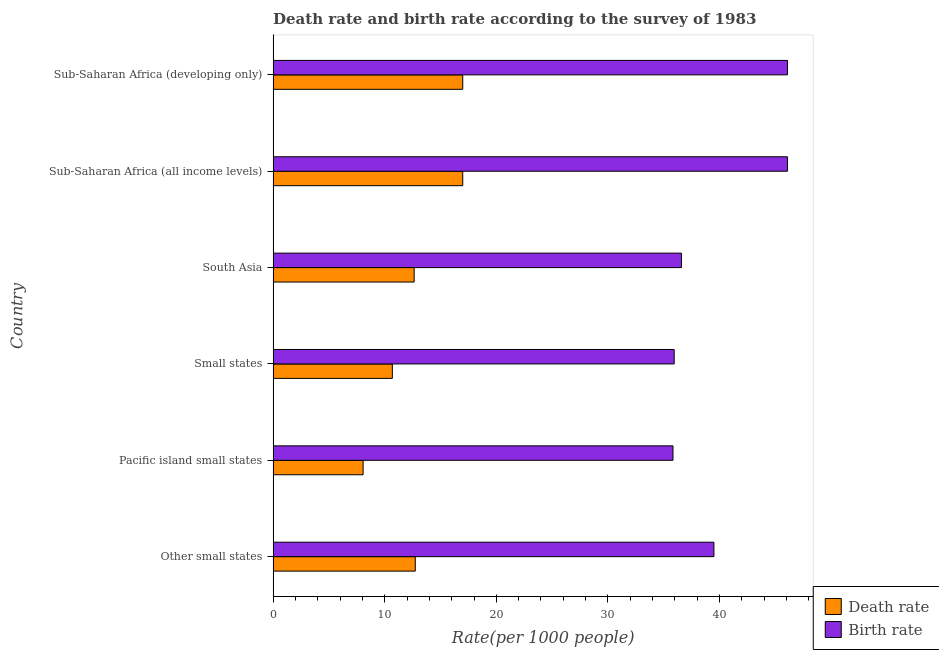How many different coloured bars are there?
Provide a short and direct response. 2. How many groups of bars are there?
Provide a short and direct response. 6. Are the number of bars on each tick of the Y-axis equal?
Give a very brief answer. Yes. What is the label of the 6th group of bars from the top?
Make the answer very short. Other small states. In how many cases, is the number of bars for a given country not equal to the number of legend labels?
Provide a succinct answer. 0. What is the death rate in Other small states?
Provide a short and direct response. 12.74. Across all countries, what is the maximum death rate?
Give a very brief answer. 16.99. Across all countries, what is the minimum death rate?
Provide a succinct answer. 8.06. In which country was the birth rate maximum?
Offer a very short reply. Sub-Saharan Africa (developing only). In which country was the birth rate minimum?
Give a very brief answer. Pacific island small states. What is the total death rate in the graph?
Your answer should be very brief. 78.1. What is the difference between the birth rate in Pacific island small states and that in Small states?
Provide a short and direct response. -0.11. What is the difference between the birth rate in Sub-Saharan Africa (all income levels) and the death rate in Sub-Saharan Africa (developing only)?
Provide a succinct answer. 29.1. What is the average birth rate per country?
Offer a terse response. 40.01. What is the difference between the death rate and birth rate in South Asia?
Provide a short and direct response. -23.95. In how many countries, is the birth rate greater than 20 ?
Provide a short and direct response. 6. Is the birth rate in Other small states less than that in South Asia?
Keep it short and to the point. No. Is the difference between the death rate in Pacific island small states and Sub-Saharan Africa (all income levels) greater than the difference between the birth rate in Pacific island small states and Sub-Saharan Africa (all income levels)?
Keep it short and to the point. Yes. What is the difference between the highest and the lowest birth rate?
Provide a short and direct response. 10.26. Is the sum of the birth rate in Other small states and Small states greater than the maximum death rate across all countries?
Offer a very short reply. Yes. What does the 1st bar from the top in Small states represents?
Provide a short and direct response. Birth rate. What does the 2nd bar from the bottom in South Asia represents?
Make the answer very short. Birth rate. How many bars are there?
Your answer should be very brief. 12. How many countries are there in the graph?
Provide a short and direct response. 6. Does the graph contain any zero values?
Ensure brevity in your answer.  No. Does the graph contain grids?
Your answer should be very brief. No. Where does the legend appear in the graph?
Provide a short and direct response. Bottom right. How many legend labels are there?
Your answer should be compact. 2. How are the legend labels stacked?
Make the answer very short. Vertical. What is the title of the graph?
Your answer should be compact. Death rate and birth rate according to the survey of 1983. Does "Automatic Teller Machines" appear as one of the legend labels in the graph?
Provide a succinct answer. No. What is the label or title of the X-axis?
Give a very brief answer. Rate(per 1000 people). What is the label or title of the Y-axis?
Give a very brief answer. Country. What is the Rate(per 1000 people) of Death rate in Other small states?
Provide a short and direct response. 12.74. What is the Rate(per 1000 people) in Birth rate in Other small states?
Give a very brief answer. 39.5. What is the Rate(per 1000 people) in Death rate in Pacific island small states?
Provide a succinct answer. 8.06. What is the Rate(per 1000 people) in Birth rate in Pacific island small states?
Make the answer very short. 35.83. What is the Rate(per 1000 people) in Death rate in Small states?
Provide a succinct answer. 10.68. What is the Rate(per 1000 people) in Birth rate in Small states?
Offer a very short reply. 35.94. What is the Rate(per 1000 people) of Death rate in South Asia?
Your answer should be compact. 12.64. What is the Rate(per 1000 people) in Birth rate in South Asia?
Your response must be concise. 36.59. What is the Rate(per 1000 people) of Death rate in Sub-Saharan Africa (all income levels)?
Your response must be concise. 16.99. What is the Rate(per 1000 people) of Birth rate in Sub-Saharan Africa (all income levels)?
Ensure brevity in your answer.  46.09. What is the Rate(per 1000 people) of Death rate in Sub-Saharan Africa (developing only)?
Give a very brief answer. 16.99. What is the Rate(per 1000 people) of Birth rate in Sub-Saharan Africa (developing only)?
Provide a short and direct response. 46.09. Across all countries, what is the maximum Rate(per 1000 people) in Death rate?
Make the answer very short. 16.99. Across all countries, what is the maximum Rate(per 1000 people) of Birth rate?
Make the answer very short. 46.09. Across all countries, what is the minimum Rate(per 1000 people) in Death rate?
Provide a short and direct response. 8.06. Across all countries, what is the minimum Rate(per 1000 people) in Birth rate?
Your response must be concise. 35.83. What is the total Rate(per 1000 people) in Death rate in the graph?
Provide a succinct answer. 78.1. What is the total Rate(per 1000 people) in Birth rate in the graph?
Your response must be concise. 240.04. What is the difference between the Rate(per 1000 people) in Death rate in Other small states and that in Pacific island small states?
Provide a succinct answer. 4.68. What is the difference between the Rate(per 1000 people) of Birth rate in Other small states and that in Pacific island small states?
Ensure brevity in your answer.  3.67. What is the difference between the Rate(per 1000 people) in Death rate in Other small states and that in Small states?
Ensure brevity in your answer.  2.06. What is the difference between the Rate(per 1000 people) of Birth rate in Other small states and that in Small states?
Your answer should be compact. 3.56. What is the difference between the Rate(per 1000 people) of Death rate in Other small states and that in South Asia?
Ensure brevity in your answer.  0.1. What is the difference between the Rate(per 1000 people) of Birth rate in Other small states and that in South Asia?
Your response must be concise. 2.91. What is the difference between the Rate(per 1000 people) in Death rate in Other small states and that in Sub-Saharan Africa (all income levels)?
Offer a terse response. -4.25. What is the difference between the Rate(per 1000 people) in Birth rate in Other small states and that in Sub-Saharan Africa (all income levels)?
Keep it short and to the point. -6.59. What is the difference between the Rate(per 1000 people) in Death rate in Other small states and that in Sub-Saharan Africa (developing only)?
Your answer should be very brief. -4.25. What is the difference between the Rate(per 1000 people) in Birth rate in Other small states and that in Sub-Saharan Africa (developing only)?
Your answer should be compact. -6.59. What is the difference between the Rate(per 1000 people) of Death rate in Pacific island small states and that in Small states?
Give a very brief answer. -2.62. What is the difference between the Rate(per 1000 people) of Birth rate in Pacific island small states and that in Small states?
Give a very brief answer. -0.11. What is the difference between the Rate(per 1000 people) in Death rate in Pacific island small states and that in South Asia?
Offer a very short reply. -4.58. What is the difference between the Rate(per 1000 people) of Birth rate in Pacific island small states and that in South Asia?
Give a very brief answer. -0.76. What is the difference between the Rate(per 1000 people) in Death rate in Pacific island small states and that in Sub-Saharan Africa (all income levels)?
Your answer should be very brief. -8.93. What is the difference between the Rate(per 1000 people) of Birth rate in Pacific island small states and that in Sub-Saharan Africa (all income levels)?
Provide a succinct answer. -10.26. What is the difference between the Rate(per 1000 people) of Death rate in Pacific island small states and that in Sub-Saharan Africa (developing only)?
Make the answer very short. -8.93. What is the difference between the Rate(per 1000 people) in Birth rate in Pacific island small states and that in Sub-Saharan Africa (developing only)?
Provide a short and direct response. -10.26. What is the difference between the Rate(per 1000 people) of Death rate in Small states and that in South Asia?
Offer a very short reply. -1.96. What is the difference between the Rate(per 1000 people) of Birth rate in Small states and that in South Asia?
Provide a short and direct response. -0.65. What is the difference between the Rate(per 1000 people) in Death rate in Small states and that in Sub-Saharan Africa (all income levels)?
Your answer should be compact. -6.31. What is the difference between the Rate(per 1000 people) in Birth rate in Small states and that in Sub-Saharan Africa (all income levels)?
Provide a succinct answer. -10.15. What is the difference between the Rate(per 1000 people) of Death rate in Small states and that in Sub-Saharan Africa (developing only)?
Give a very brief answer. -6.31. What is the difference between the Rate(per 1000 people) of Birth rate in Small states and that in Sub-Saharan Africa (developing only)?
Offer a terse response. -10.16. What is the difference between the Rate(per 1000 people) of Death rate in South Asia and that in Sub-Saharan Africa (all income levels)?
Provide a short and direct response. -4.35. What is the difference between the Rate(per 1000 people) in Birth rate in South Asia and that in Sub-Saharan Africa (all income levels)?
Provide a succinct answer. -9.5. What is the difference between the Rate(per 1000 people) of Death rate in South Asia and that in Sub-Saharan Africa (developing only)?
Provide a succinct answer. -4.35. What is the difference between the Rate(per 1000 people) in Birth rate in South Asia and that in Sub-Saharan Africa (developing only)?
Offer a very short reply. -9.5. What is the difference between the Rate(per 1000 people) in Birth rate in Sub-Saharan Africa (all income levels) and that in Sub-Saharan Africa (developing only)?
Your answer should be compact. -0.01. What is the difference between the Rate(per 1000 people) of Death rate in Other small states and the Rate(per 1000 people) of Birth rate in Pacific island small states?
Your response must be concise. -23.09. What is the difference between the Rate(per 1000 people) of Death rate in Other small states and the Rate(per 1000 people) of Birth rate in Small states?
Your answer should be very brief. -23.2. What is the difference between the Rate(per 1000 people) of Death rate in Other small states and the Rate(per 1000 people) of Birth rate in South Asia?
Offer a very short reply. -23.85. What is the difference between the Rate(per 1000 people) in Death rate in Other small states and the Rate(per 1000 people) in Birth rate in Sub-Saharan Africa (all income levels)?
Keep it short and to the point. -33.35. What is the difference between the Rate(per 1000 people) of Death rate in Other small states and the Rate(per 1000 people) of Birth rate in Sub-Saharan Africa (developing only)?
Your response must be concise. -33.36. What is the difference between the Rate(per 1000 people) of Death rate in Pacific island small states and the Rate(per 1000 people) of Birth rate in Small states?
Your answer should be very brief. -27.88. What is the difference between the Rate(per 1000 people) in Death rate in Pacific island small states and the Rate(per 1000 people) in Birth rate in South Asia?
Provide a succinct answer. -28.53. What is the difference between the Rate(per 1000 people) in Death rate in Pacific island small states and the Rate(per 1000 people) in Birth rate in Sub-Saharan Africa (all income levels)?
Provide a short and direct response. -38.03. What is the difference between the Rate(per 1000 people) of Death rate in Pacific island small states and the Rate(per 1000 people) of Birth rate in Sub-Saharan Africa (developing only)?
Your answer should be very brief. -38.03. What is the difference between the Rate(per 1000 people) of Death rate in Small states and the Rate(per 1000 people) of Birth rate in South Asia?
Provide a short and direct response. -25.91. What is the difference between the Rate(per 1000 people) of Death rate in Small states and the Rate(per 1000 people) of Birth rate in Sub-Saharan Africa (all income levels)?
Ensure brevity in your answer.  -35.41. What is the difference between the Rate(per 1000 people) in Death rate in Small states and the Rate(per 1000 people) in Birth rate in Sub-Saharan Africa (developing only)?
Keep it short and to the point. -35.41. What is the difference between the Rate(per 1000 people) of Death rate in South Asia and the Rate(per 1000 people) of Birth rate in Sub-Saharan Africa (all income levels)?
Provide a short and direct response. -33.45. What is the difference between the Rate(per 1000 people) in Death rate in South Asia and the Rate(per 1000 people) in Birth rate in Sub-Saharan Africa (developing only)?
Keep it short and to the point. -33.45. What is the difference between the Rate(per 1000 people) of Death rate in Sub-Saharan Africa (all income levels) and the Rate(per 1000 people) of Birth rate in Sub-Saharan Africa (developing only)?
Offer a very short reply. -29.1. What is the average Rate(per 1000 people) in Death rate per country?
Make the answer very short. 13.02. What is the average Rate(per 1000 people) in Birth rate per country?
Give a very brief answer. 40.01. What is the difference between the Rate(per 1000 people) of Death rate and Rate(per 1000 people) of Birth rate in Other small states?
Give a very brief answer. -26.76. What is the difference between the Rate(per 1000 people) of Death rate and Rate(per 1000 people) of Birth rate in Pacific island small states?
Your answer should be compact. -27.77. What is the difference between the Rate(per 1000 people) in Death rate and Rate(per 1000 people) in Birth rate in Small states?
Provide a short and direct response. -25.26. What is the difference between the Rate(per 1000 people) of Death rate and Rate(per 1000 people) of Birth rate in South Asia?
Your response must be concise. -23.95. What is the difference between the Rate(per 1000 people) in Death rate and Rate(per 1000 people) in Birth rate in Sub-Saharan Africa (all income levels)?
Provide a short and direct response. -29.1. What is the difference between the Rate(per 1000 people) of Death rate and Rate(per 1000 people) of Birth rate in Sub-Saharan Africa (developing only)?
Keep it short and to the point. -29.1. What is the ratio of the Rate(per 1000 people) of Death rate in Other small states to that in Pacific island small states?
Your answer should be very brief. 1.58. What is the ratio of the Rate(per 1000 people) in Birth rate in Other small states to that in Pacific island small states?
Keep it short and to the point. 1.1. What is the ratio of the Rate(per 1000 people) of Death rate in Other small states to that in Small states?
Provide a short and direct response. 1.19. What is the ratio of the Rate(per 1000 people) in Birth rate in Other small states to that in Small states?
Provide a short and direct response. 1.1. What is the ratio of the Rate(per 1000 people) in Death rate in Other small states to that in South Asia?
Your answer should be compact. 1.01. What is the ratio of the Rate(per 1000 people) in Birth rate in Other small states to that in South Asia?
Your response must be concise. 1.08. What is the ratio of the Rate(per 1000 people) in Death rate in Other small states to that in Sub-Saharan Africa (all income levels)?
Your answer should be compact. 0.75. What is the ratio of the Rate(per 1000 people) in Birth rate in Other small states to that in Sub-Saharan Africa (all income levels)?
Give a very brief answer. 0.86. What is the ratio of the Rate(per 1000 people) in Death rate in Other small states to that in Sub-Saharan Africa (developing only)?
Offer a terse response. 0.75. What is the ratio of the Rate(per 1000 people) of Birth rate in Other small states to that in Sub-Saharan Africa (developing only)?
Offer a terse response. 0.86. What is the ratio of the Rate(per 1000 people) in Death rate in Pacific island small states to that in Small states?
Make the answer very short. 0.75. What is the ratio of the Rate(per 1000 people) in Death rate in Pacific island small states to that in South Asia?
Provide a succinct answer. 0.64. What is the ratio of the Rate(per 1000 people) of Birth rate in Pacific island small states to that in South Asia?
Provide a succinct answer. 0.98. What is the ratio of the Rate(per 1000 people) of Death rate in Pacific island small states to that in Sub-Saharan Africa (all income levels)?
Give a very brief answer. 0.47. What is the ratio of the Rate(per 1000 people) of Birth rate in Pacific island small states to that in Sub-Saharan Africa (all income levels)?
Provide a short and direct response. 0.78. What is the ratio of the Rate(per 1000 people) of Death rate in Pacific island small states to that in Sub-Saharan Africa (developing only)?
Give a very brief answer. 0.47. What is the ratio of the Rate(per 1000 people) of Birth rate in Pacific island small states to that in Sub-Saharan Africa (developing only)?
Provide a succinct answer. 0.78. What is the ratio of the Rate(per 1000 people) in Death rate in Small states to that in South Asia?
Your response must be concise. 0.85. What is the ratio of the Rate(per 1000 people) of Birth rate in Small states to that in South Asia?
Make the answer very short. 0.98. What is the ratio of the Rate(per 1000 people) in Death rate in Small states to that in Sub-Saharan Africa (all income levels)?
Make the answer very short. 0.63. What is the ratio of the Rate(per 1000 people) in Birth rate in Small states to that in Sub-Saharan Africa (all income levels)?
Ensure brevity in your answer.  0.78. What is the ratio of the Rate(per 1000 people) of Death rate in Small states to that in Sub-Saharan Africa (developing only)?
Ensure brevity in your answer.  0.63. What is the ratio of the Rate(per 1000 people) in Birth rate in Small states to that in Sub-Saharan Africa (developing only)?
Provide a short and direct response. 0.78. What is the ratio of the Rate(per 1000 people) of Death rate in South Asia to that in Sub-Saharan Africa (all income levels)?
Give a very brief answer. 0.74. What is the ratio of the Rate(per 1000 people) of Birth rate in South Asia to that in Sub-Saharan Africa (all income levels)?
Make the answer very short. 0.79. What is the ratio of the Rate(per 1000 people) in Death rate in South Asia to that in Sub-Saharan Africa (developing only)?
Offer a terse response. 0.74. What is the ratio of the Rate(per 1000 people) in Birth rate in South Asia to that in Sub-Saharan Africa (developing only)?
Keep it short and to the point. 0.79. What is the ratio of the Rate(per 1000 people) in Death rate in Sub-Saharan Africa (all income levels) to that in Sub-Saharan Africa (developing only)?
Provide a succinct answer. 1. What is the ratio of the Rate(per 1000 people) in Birth rate in Sub-Saharan Africa (all income levels) to that in Sub-Saharan Africa (developing only)?
Make the answer very short. 1. What is the difference between the highest and the second highest Rate(per 1000 people) of Death rate?
Ensure brevity in your answer.  0. What is the difference between the highest and the second highest Rate(per 1000 people) in Birth rate?
Ensure brevity in your answer.  0.01. What is the difference between the highest and the lowest Rate(per 1000 people) of Death rate?
Keep it short and to the point. 8.93. What is the difference between the highest and the lowest Rate(per 1000 people) in Birth rate?
Provide a short and direct response. 10.26. 